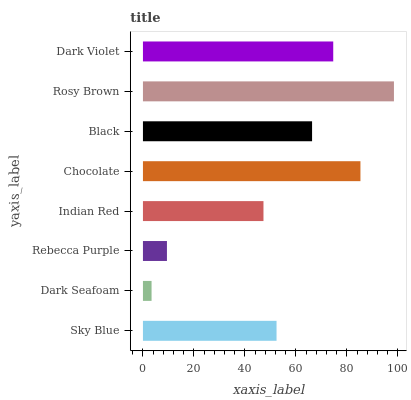Is Dark Seafoam the minimum?
Answer yes or no. Yes. Is Rosy Brown the maximum?
Answer yes or no. Yes. Is Rebecca Purple the minimum?
Answer yes or no. No. Is Rebecca Purple the maximum?
Answer yes or no. No. Is Rebecca Purple greater than Dark Seafoam?
Answer yes or no. Yes. Is Dark Seafoam less than Rebecca Purple?
Answer yes or no. Yes. Is Dark Seafoam greater than Rebecca Purple?
Answer yes or no. No. Is Rebecca Purple less than Dark Seafoam?
Answer yes or no. No. Is Black the high median?
Answer yes or no. Yes. Is Sky Blue the low median?
Answer yes or no. Yes. Is Sky Blue the high median?
Answer yes or no. No. Is Dark Violet the low median?
Answer yes or no. No. 